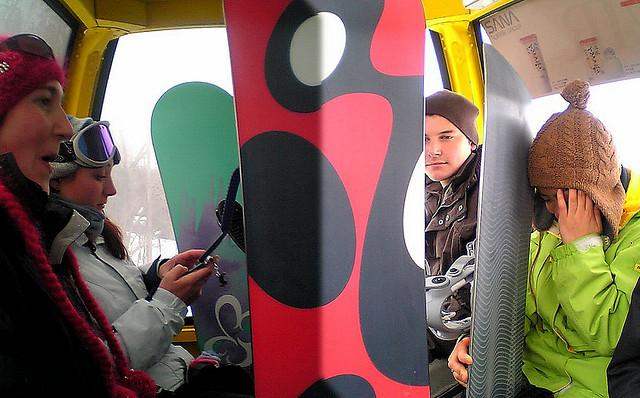What winter sport is this group participating in? Please explain your reasoning. snowboarding. They are on a lift to go up the mountain to snow board down it. 